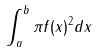Convert formula to latex. <formula><loc_0><loc_0><loc_500><loc_500>\int _ { a } ^ { b } \pi f ( x ) ^ { 2 } d x</formula> 